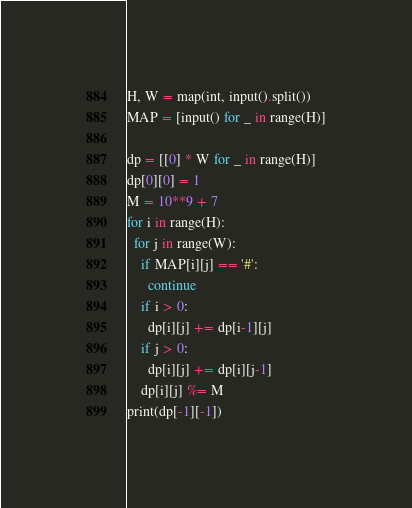<code> <loc_0><loc_0><loc_500><loc_500><_Python_>H, W = map(int, input().split())
MAP = [input() for _ in range(H)]

dp = [[0] * W for _ in range(H)]
dp[0][0] = 1
M = 10**9 + 7
for i in range(H):
  for j in range(W):
    if MAP[i][j] == '#':
      continue
    if i > 0:
      dp[i][j] += dp[i-1][j]
    if j > 0:
      dp[i][j] += dp[i][j-1]
    dp[i][j] %= M
print(dp[-1][-1])</code> 